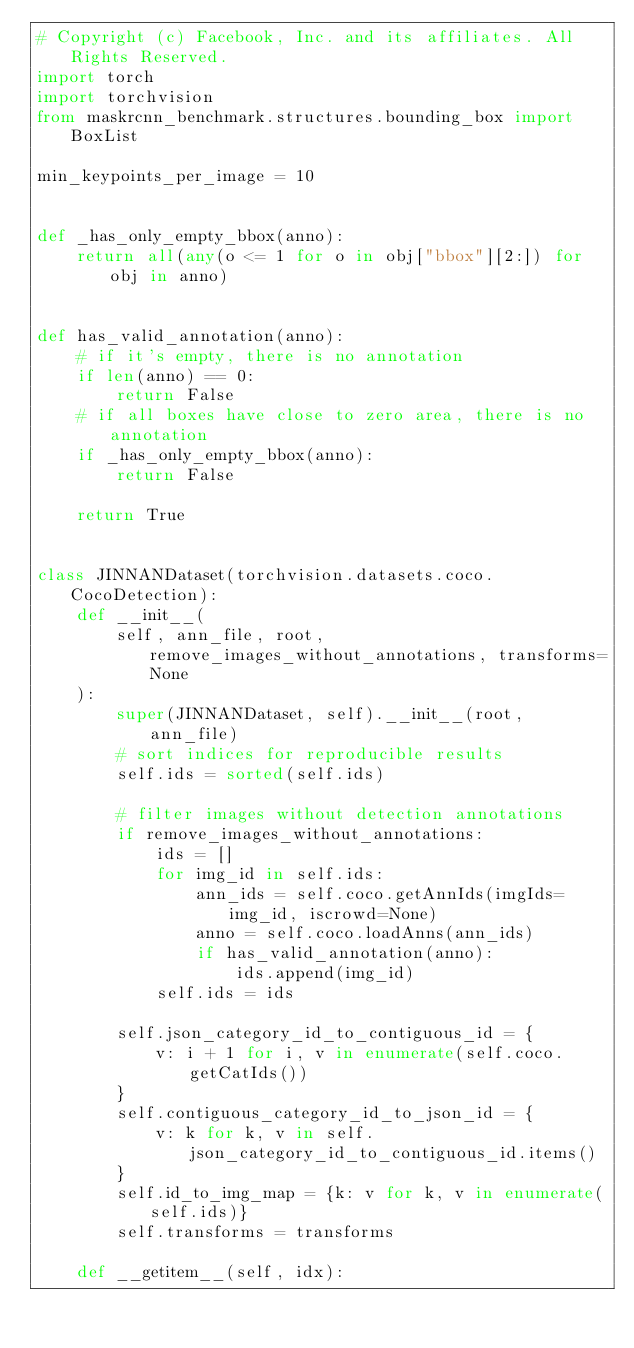Convert code to text. <code><loc_0><loc_0><loc_500><loc_500><_Python_># Copyright (c) Facebook, Inc. and its affiliates. All Rights Reserved.
import torch
import torchvision
from maskrcnn_benchmark.structures.bounding_box import BoxList

min_keypoints_per_image = 10


def _has_only_empty_bbox(anno):
    return all(any(o <= 1 for o in obj["bbox"][2:]) for obj in anno)


def has_valid_annotation(anno):
    # if it's empty, there is no annotation
    if len(anno) == 0:
        return False
    # if all boxes have close to zero area, there is no annotation
    if _has_only_empty_bbox(anno):
        return False

    return True


class JINNANDataset(torchvision.datasets.coco.CocoDetection):
    def __init__(
        self, ann_file, root, remove_images_without_annotations, transforms=None
    ):
        super(JINNANDataset, self).__init__(root, ann_file)
        # sort indices for reproducible results
        self.ids = sorted(self.ids)

        # filter images without detection annotations
        if remove_images_without_annotations:
            ids = []
            for img_id in self.ids:
                ann_ids = self.coco.getAnnIds(imgIds=img_id, iscrowd=None)
                anno = self.coco.loadAnns(ann_ids)
                if has_valid_annotation(anno):
                    ids.append(img_id)
            self.ids = ids

        self.json_category_id_to_contiguous_id = {
            v: i + 1 for i, v in enumerate(self.coco.getCatIds())
        }
        self.contiguous_category_id_to_json_id = {
            v: k for k, v in self.json_category_id_to_contiguous_id.items()
        }
        self.id_to_img_map = {k: v for k, v in enumerate(self.ids)}
        self.transforms = transforms

    def __getitem__(self, idx):</code> 